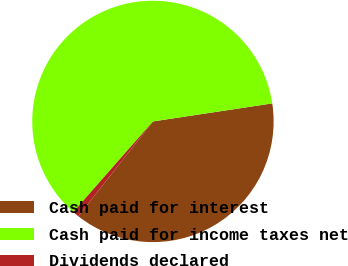Convert chart to OTSL. <chart><loc_0><loc_0><loc_500><loc_500><pie_chart><fcel>Cash paid for interest<fcel>Cash paid for income taxes net<fcel>Dividends declared<nl><fcel>38.0%<fcel>61.14%<fcel>0.86%<nl></chart> 